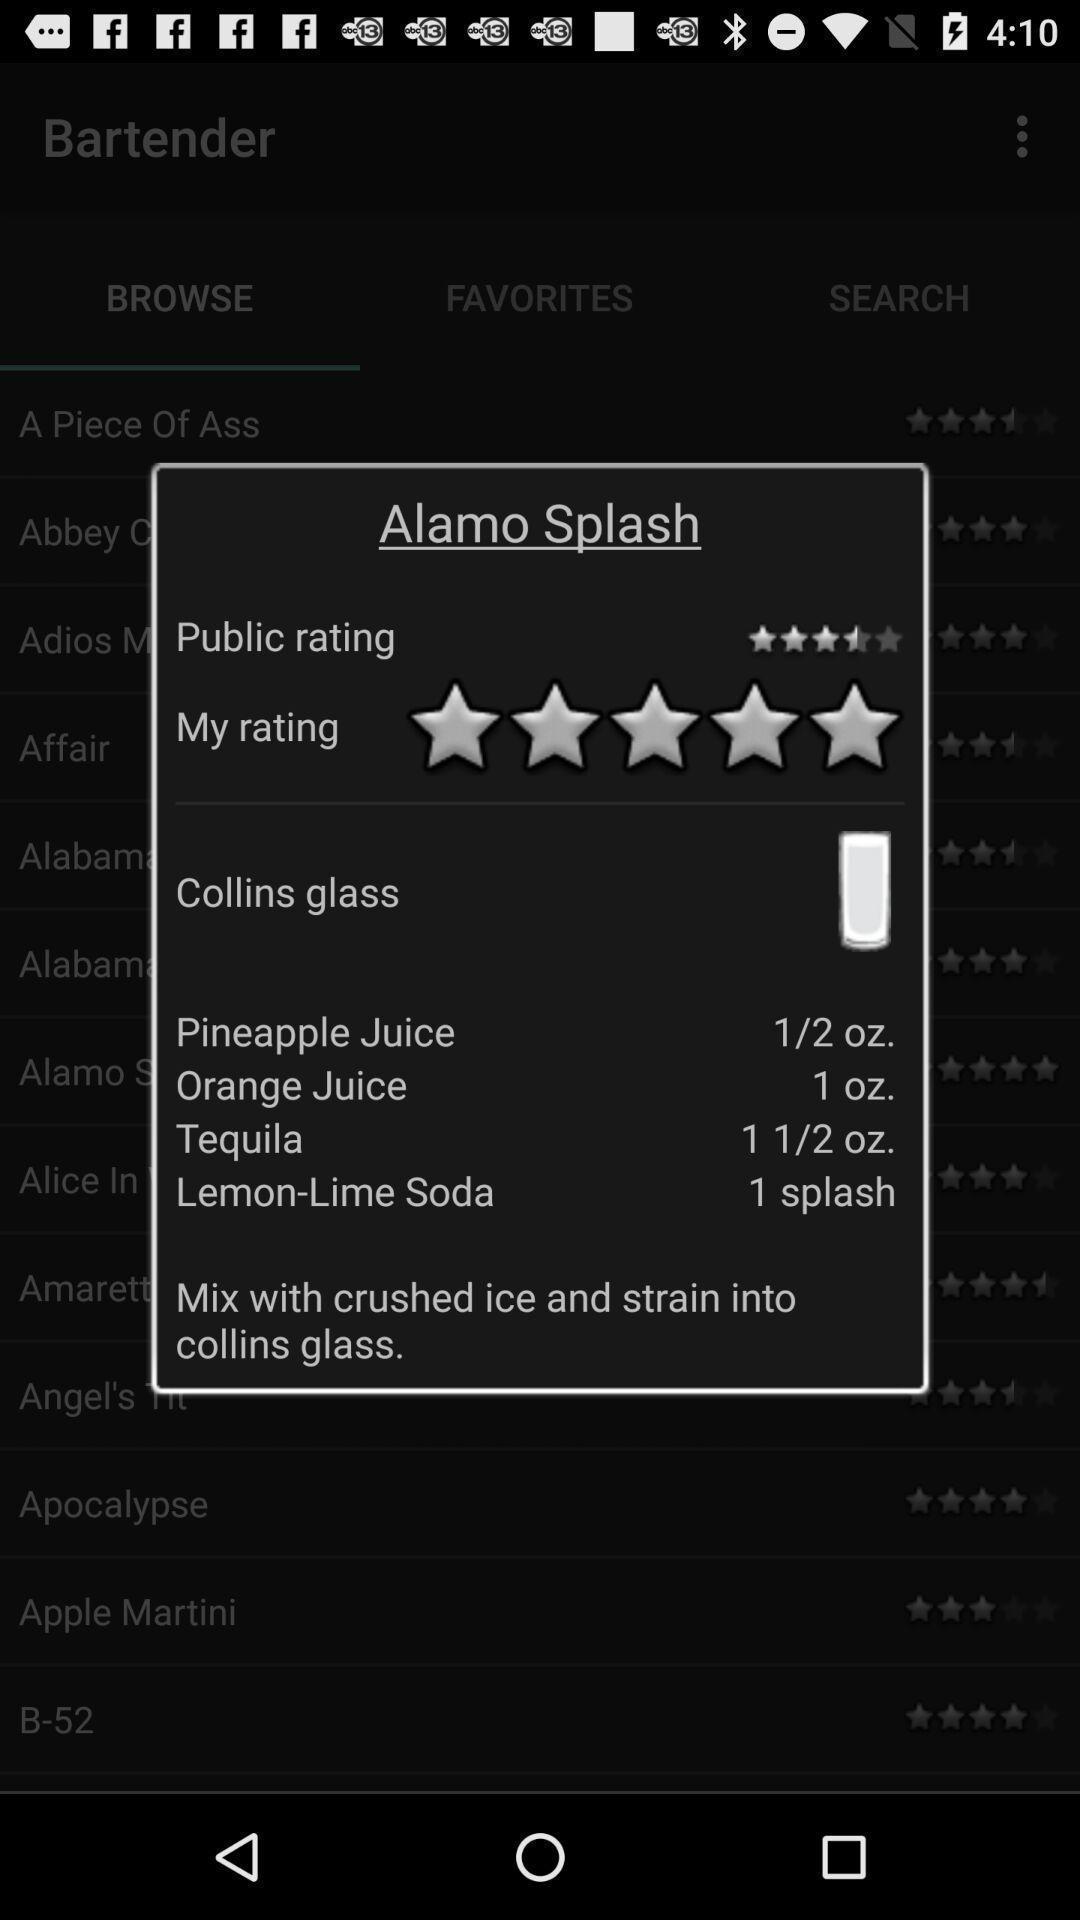What is the overall content of this screenshot? Pop-up showing food rating in food app. 